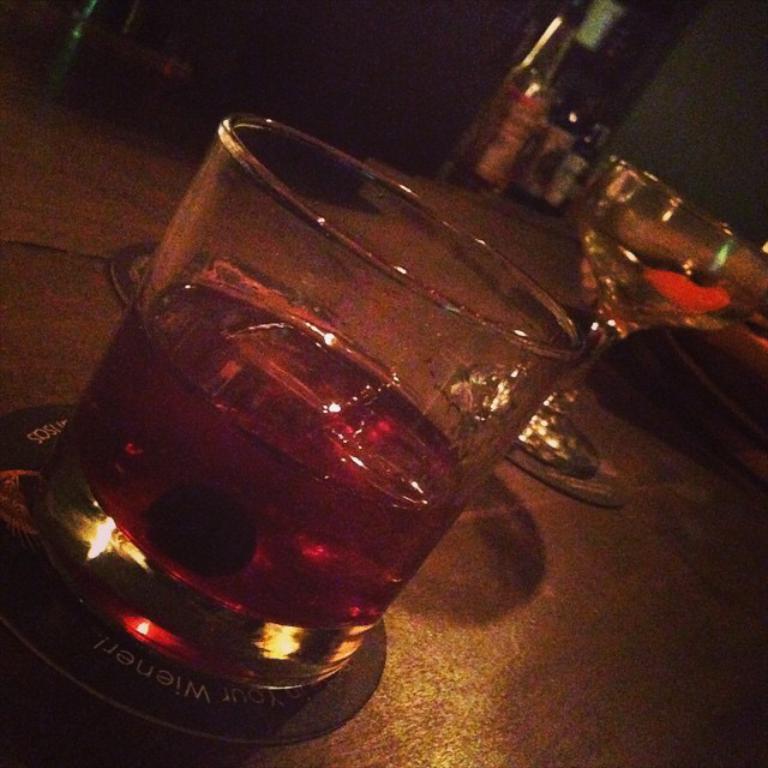How would you summarize this image in a sentence or two? On the table to the front corner there is a glass with wine in it. And to the right side there is another glass with some liquid in it. And behind table to the top right corner there are three bottles. 